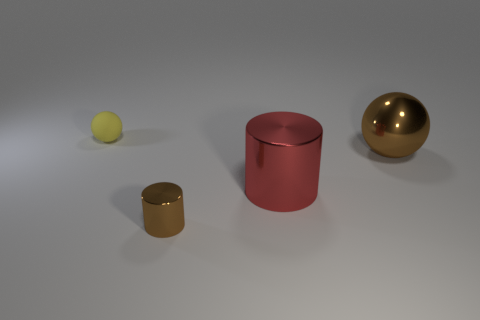Subtract 1 balls. How many balls are left? 1 Subtract all purple balls. Subtract all green cylinders. How many balls are left? 2 Subtract all cyan blocks. How many brown spheres are left? 1 Subtract all blue rubber things. Subtract all yellow rubber balls. How many objects are left? 3 Add 1 tiny brown things. How many tiny brown things are left? 2 Add 4 tiny things. How many tiny things exist? 6 Add 2 big cyan objects. How many objects exist? 6 Subtract all brown cylinders. How many cylinders are left? 1 Subtract 0 green spheres. How many objects are left? 4 